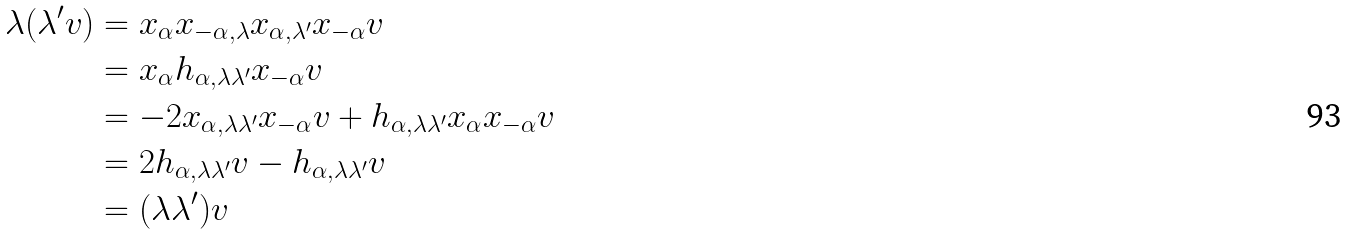<formula> <loc_0><loc_0><loc_500><loc_500>\lambda ( \lambda ^ { \prime } v ) & = x _ { \alpha } x _ { - \alpha , \lambda } x _ { \alpha , \lambda ^ { \prime } } x _ { - \alpha } v \\ & = x _ { \alpha } h _ { \alpha , \lambda \lambda ^ { \prime } } x _ { - \alpha } v \\ & = - 2 x _ { \alpha , \lambda \lambda ^ { \prime } } x _ { - \alpha } v + h _ { \alpha , \lambda \lambda ^ { \prime } } x _ { \alpha } x _ { - \alpha } v \\ & = 2 h _ { \alpha , \lambda \lambda ^ { \prime } } v - h _ { \alpha , \lambda \lambda ^ { \prime } } v \\ & = ( \lambda \lambda ^ { \prime } ) v</formula> 